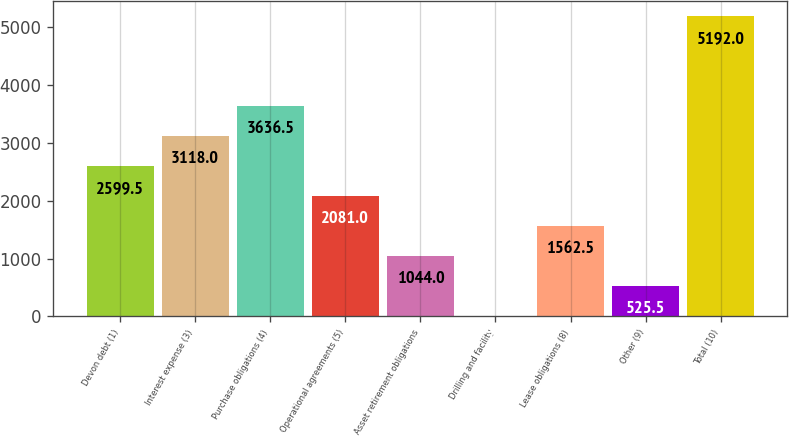<chart> <loc_0><loc_0><loc_500><loc_500><bar_chart><fcel>Devon debt (1)<fcel>Interest expense (3)<fcel>Purchase obligations (4)<fcel>Operational agreements (5)<fcel>Asset retirement obligations<fcel>Drilling and facility<fcel>Lease obligations (8)<fcel>Other (9)<fcel>Total (10)<nl><fcel>2599.5<fcel>3118<fcel>3636.5<fcel>2081<fcel>1044<fcel>7<fcel>1562.5<fcel>525.5<fcel>5192<nl></chart> 